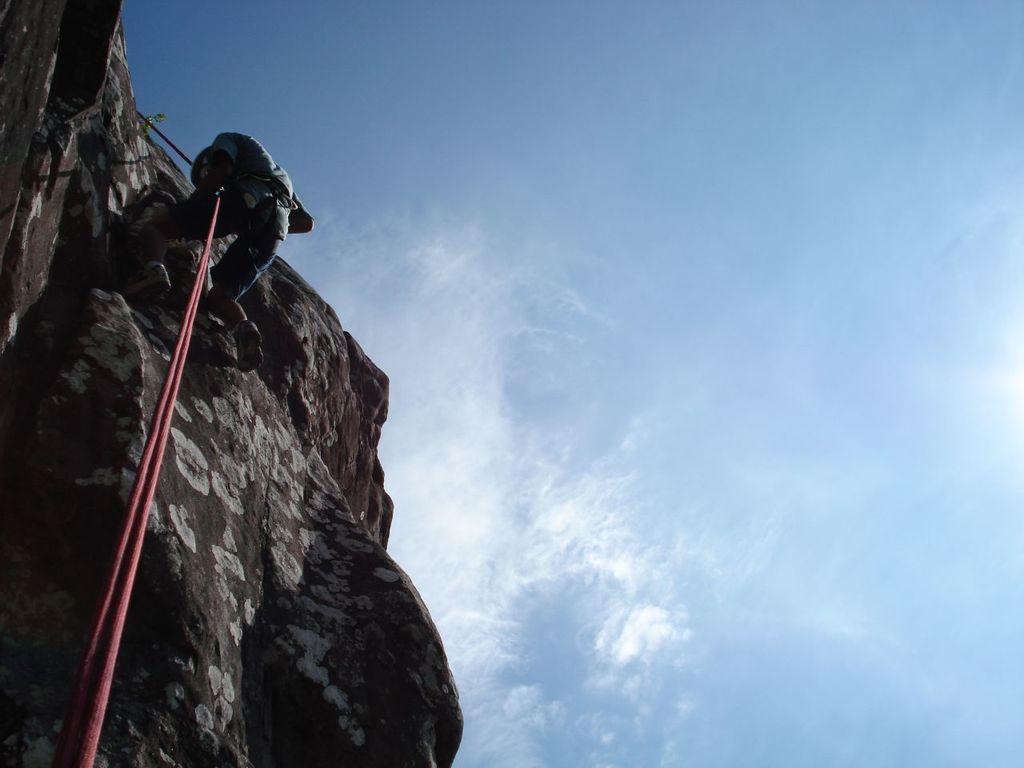In one or two sentences, can you explain what this image depicts? In this image I can see the person climbing the rock and the person is holding a rope. The rope is in red color, background the sky is in blue and white color. 